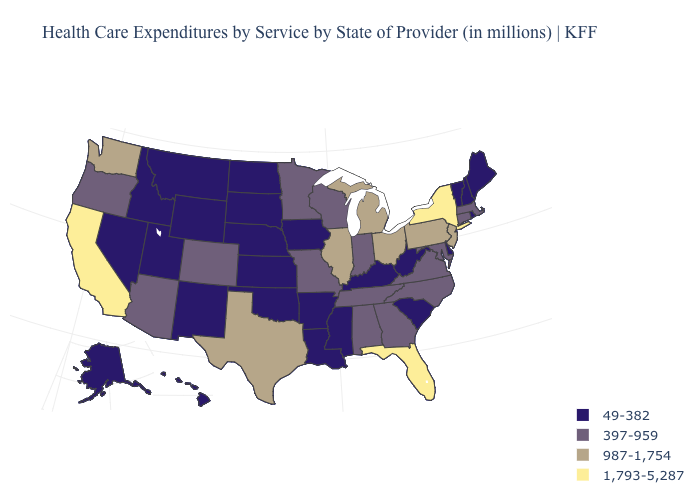What is the highest value in the MidWest ?
Write a very short answer. 987-1,754. What is the value of Mississippi?
Be succinct. 49-382. Does the map have missing data?
Short answer required. No. What is the lowest value in the South?
Answer briefly. 49-382. How many symbols are there in the legend?
Be succinct. 4. What is the highest value in the West ?
Be succinct. 1,793-5,287. Name the states that have a value in the range 987-1,754?
Concise answer only. Illinois, Michigan, New Jersey, Ohio, Pennsylvania, Texas, Washington. Name the states that have a value in the range 397-959?
Short answer required. Alabama, Arizona, Colorado, Connecticut, Georgia, Indiana, Maryland, Massachusetts, Minnesota, Missouri, North Carolina, Oregon, Tennessee, Virginia, Wisconsin. What is the lowest value in the USA?
Give a very brief answer. 49-382. Does Vermont have the highest value in the USA?
Answer briefly. No. Name the states that have a value in the range 987-1,754?
Write a very short answer. Illinois, Michigan, New Jersey, Ohio, Pennsylvania, Texas, Washington. Which states have the highest value in the USA?
Write a very short answer. California, Florida, New York. Does the map have missing data?
Concise answer only. No. Name the states that have a value in the range 397-959?
Short answer required. Alabama, Arizona, Colorado, Connecticut, Georgia, Indiana, Maryland, Massachusetts, Minnesota, Missouri, North Carolina, Oregon, Tennessee, Virginia, Wisconsin. What is the lowest value in states that border Rhode Island?
Give a very brief answer. 397-959. 